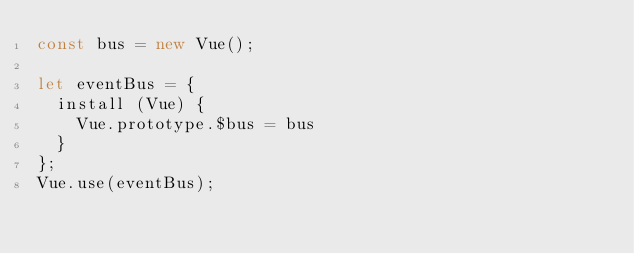<code> <loc_0><loc_0><loc_500><loc_500><_JavaScript_>const bus = new Vue();

let eventBus = {
  install (Vue) {
    Vue.prototype.$bus = bus
  }
};
Vue.use(eventBus);</code> 